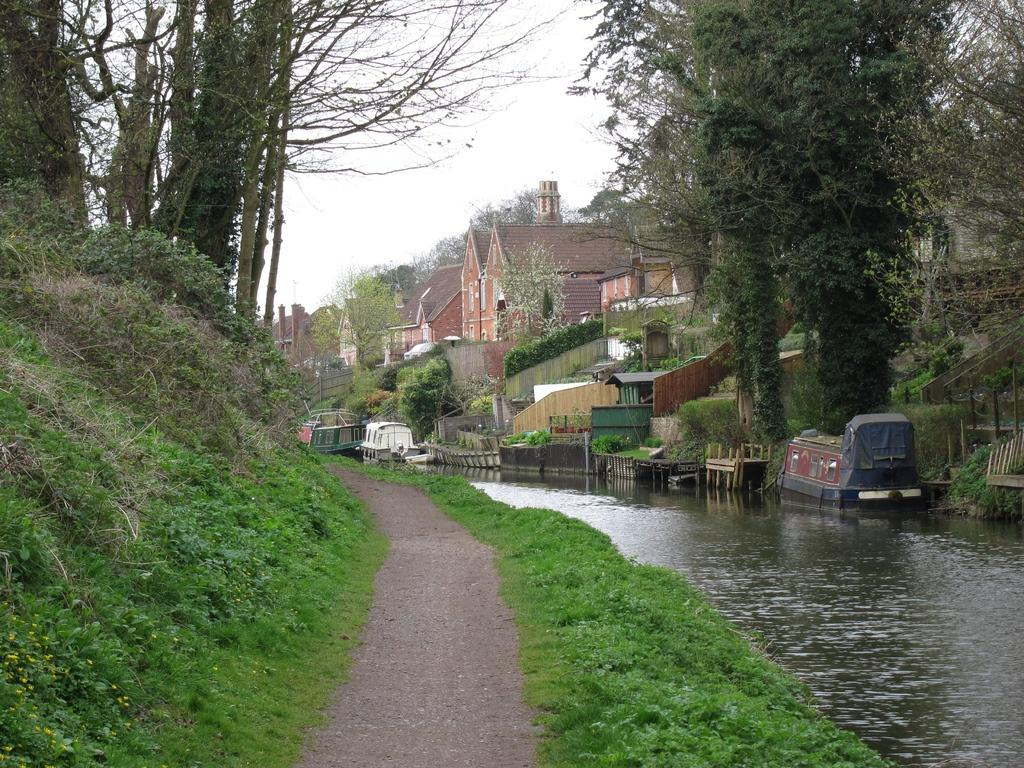What type of area is located in the front of the image? There is a walking area in the front of the image. What can be seen on the right side of the image? There is a small lake on the right side of the image. What type of houses can be seen in the background of the image? Roof top houses are visible in the background of the image. What type of vegetation is present in the background of the image? There are many trees in the background of the image. What type of bean is growing on the trees in the image? There are no beans growing on the trees in the image; it features a walking area, a small lake, roof top houses, and many trees. What idea does the image convey about the location? The image does not convey a specific idea about the location, as it only provides visual information about the walking area, small lake, roof top houses, and trees. 